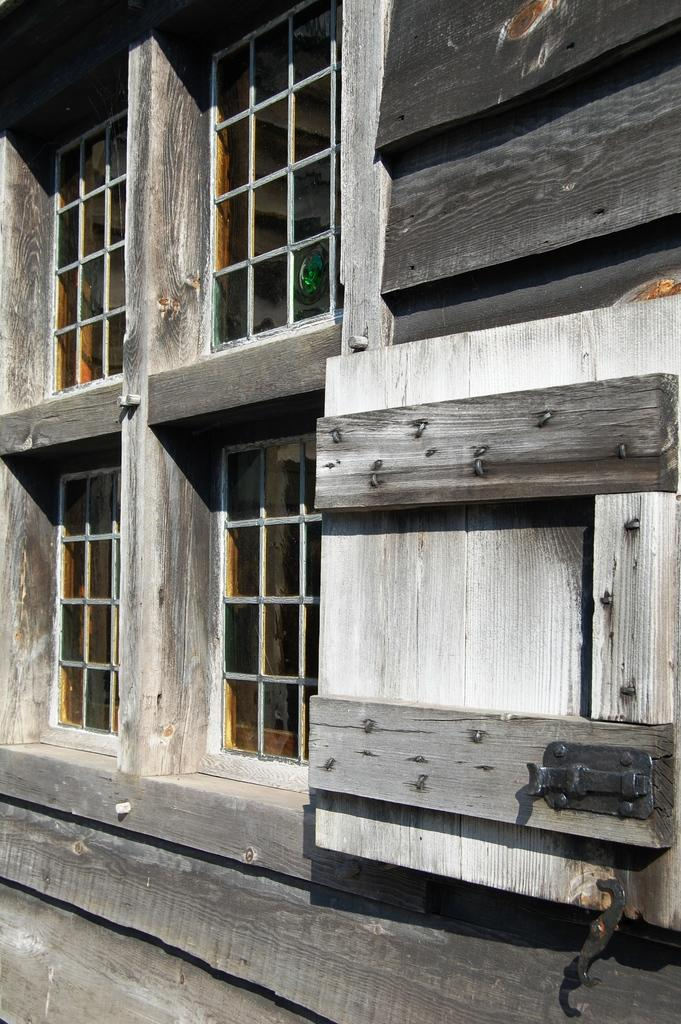What type of material is used for the wall in the image? The wall in the image is made of wood. To which structure does the wooden wall belong? The wooden wall belongs to a building. What feature can be seen on the building besides the wooden wall? There are windows on the building. How many eggs are visible on the wooden wall in the image? There are no eggs present on the wooden wall in the image. What type of quartz can be seen embedded in the wooden wall? There is no quartz present in the wooden wall in the image. 